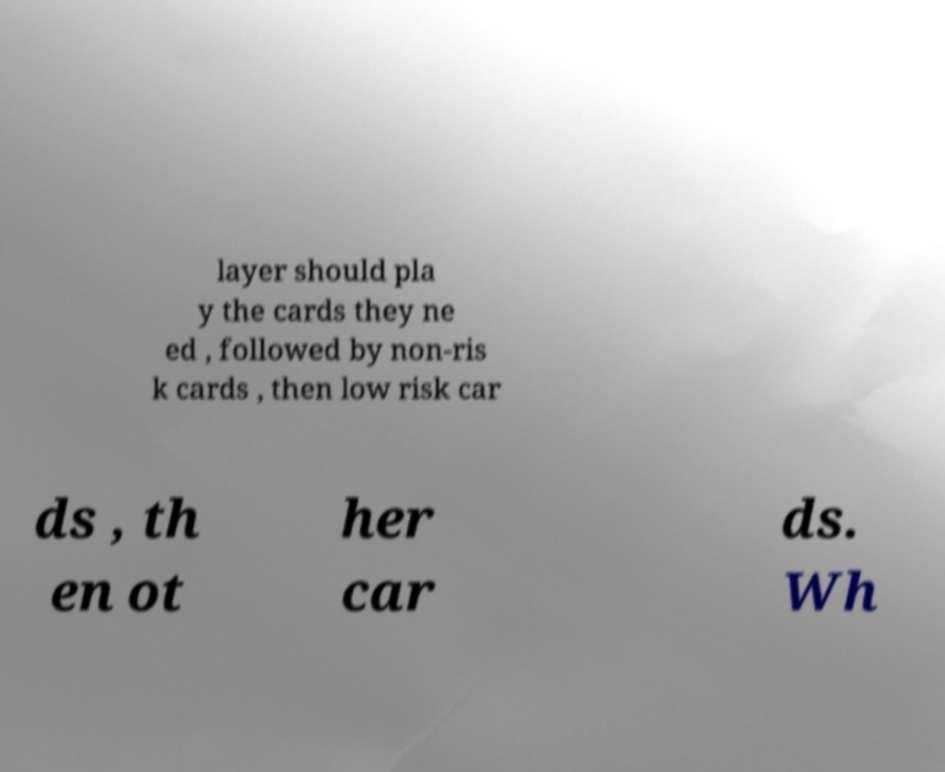Can you read and provide the text displayed in the image?This photo seems to have some interesting text. Can you extract and type it out for me? layer should pla y the cards they ne ed , followed by non-ris k cards , then low risk car ds , th en ot her car ds. Wh 